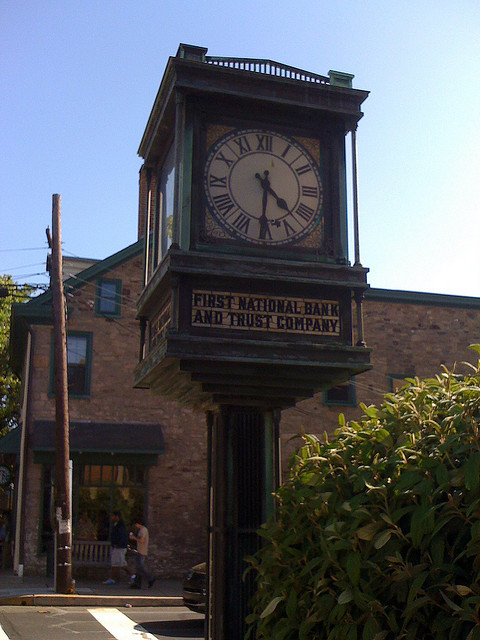Please transcribe the text in this image. FIRST NATIONAL BANK COMPANY AND XI X VIII IIII II XII 